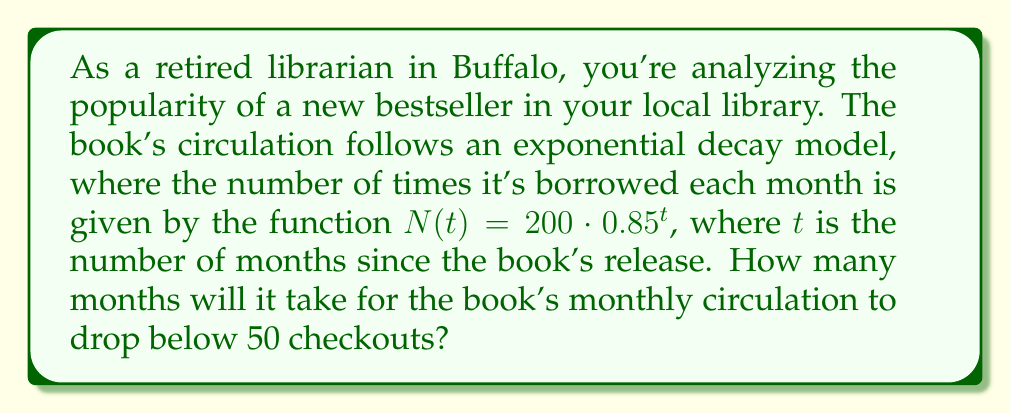Show me your answer to this math problem. To solve this problem, we need to use logarithms to determine when the exponential decay function drops below 50. Let's approach this step-by-step:

1) We want to find $t$ when $N(t) < 50$. So, we set up the inequality:

   $200 \cdot 0.85^t < 50$

2) Divide both sides by 200:

   $0.85^t < \frac{50}{200} = 0.25$

3) Now, we can take the logarithm of both sides. Since 0.85 is less than 1, the inequality sign will flip:

   $\log_{0.85}(0.85^t) > \log_{0.85}(0.25)$

4) The left side simplifies to $t$:

   $t > \log_{0.85}(0.25)$

5) We can change this to a natural log or common log. Let's use natural log:

   $t > \frac{\ln(0.25)}{\ln(0.85)}$

6) Calculate this value:

   $t > \frac{-1.3863}{-0.1625} \approx 8.53$

7) Since $t$ represents months and must be a whole number, we round up to the next integer.

Therefore, it will take 9 months for the book's circulation to drop below 50 checkouts per month.
Answer: 9 months 